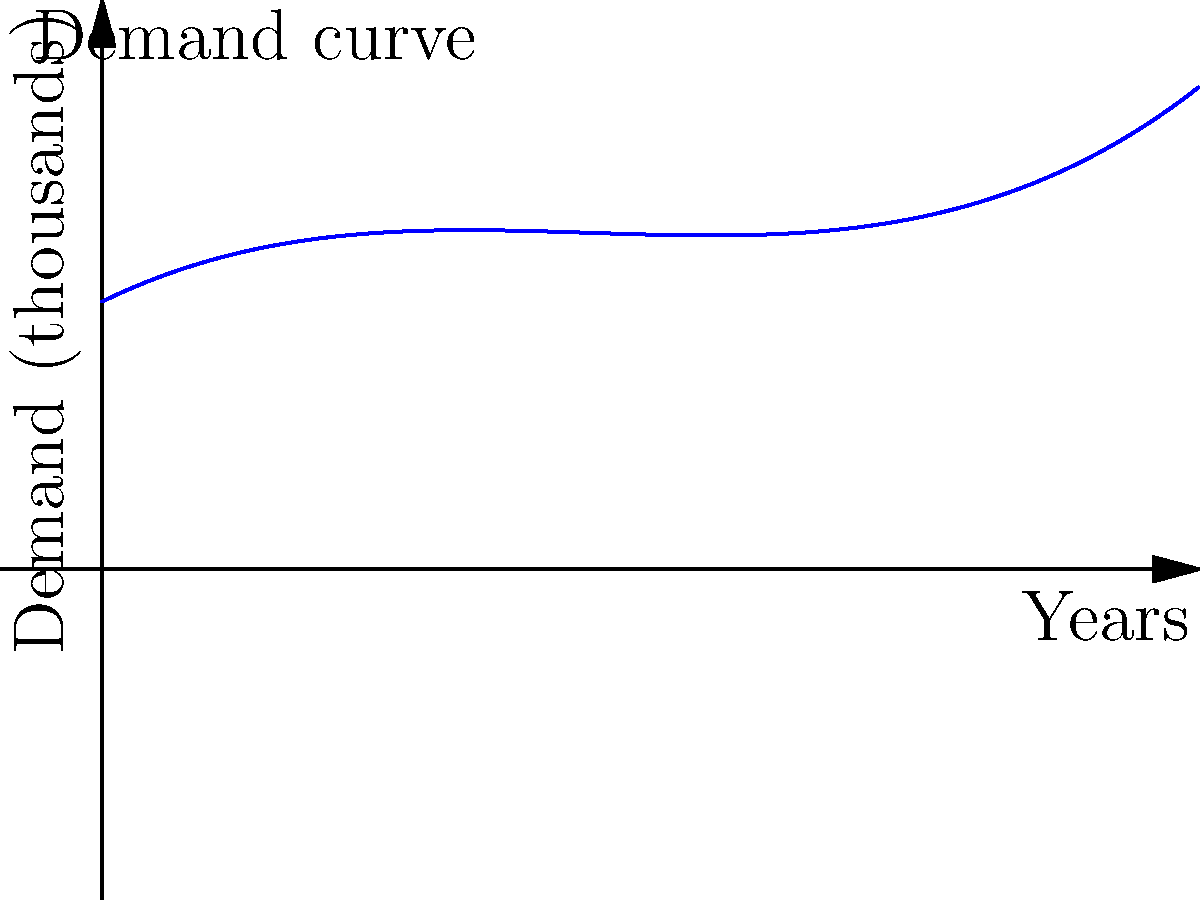As a regulatory affairs specialist, you're tasked with analyzing the market demand for a new medication. The polynomial function $f(x) = 0.5x^3 - 4x^2 + 10x + 30$ represents the projected demand (in thousands of units) over the next 6 years, where $x$ is the number of years from now. At what point in time will the demand reach its minimum within this 6-year period? To find the minimum point of the demand curve within the given time frame, we need to follow these steps:

1) First, we need to find the derivative of the function:
   $f'(x) = 1.5x^2 - 8x + 10$

2) The minimum point occurs where the derivative equals zero. So, we set $f'(x) = 0$:
   $1.5x^2 - 8x + 10 = 0$

3) This is a quadratic equation. We can solve it using the quadratic formula:
   $x = \frac{-b \pm \sqrt{b^2 - 4ac}}{2a}$

   Where $a = 1.5$, $b = -8$, and $c = 10$

4) Plugging these values into the quadratic formula:
   $x = \frac{8 \pm \sqrt{64 - 60}}{3} = \frac{8 \pm 2}{3}$

5) This gives us two solutions:
   $x_1 = \frac{8 + 2}{3} = \frac{10}{3} \approx 3.33$ years
   $x_2 = \frac{8 - 2}{3} = 2$ years

6) Since we're looking for the minimum within a 6-year period, and the function is a cubic (which has one minimum and one maximum), the minimum must occur at $x = 2$ years.

Therefore, the demand will reach its minimum 2 years from now.
Answer: 2 years 